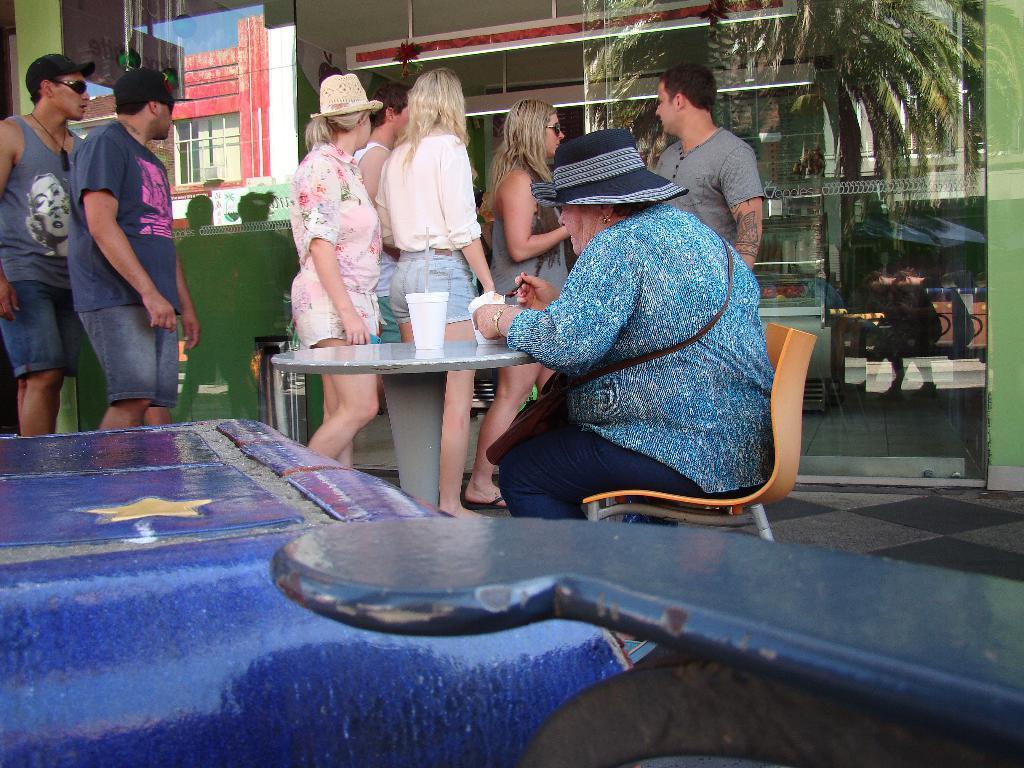How would you summarize this image in a sentence or two? In the middle of the picture, woman in blue shirt is sitting on chair in front of table on which glass, cup of ice-cream are placed and she is eating ice cream. Beside that, we see many people standing and on the left right corner of picture, we see glass from which we can see trees and buildings. On the left bottom of picture, we see a table which is covered with blue cloth. 